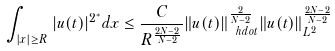Convert formula to latex. <formula><loc_0><loc_0><loc_500><loc_500>\int _ { | x | \geq R } | u ( t ) | ^ { 2 ^ { * } } d x \leq \frac { C } { R ^ { \frac { 2 N - 2 } { N - 2 } } } \| u ( t ) \| _ { \ h d o t } ^ { \frac { 2 } { N - 2 } } \| u ( t ) \| _ { L ^ { 2 } } ^ { \frac { 2 N - 2 } { N - 2 } }</formula> 